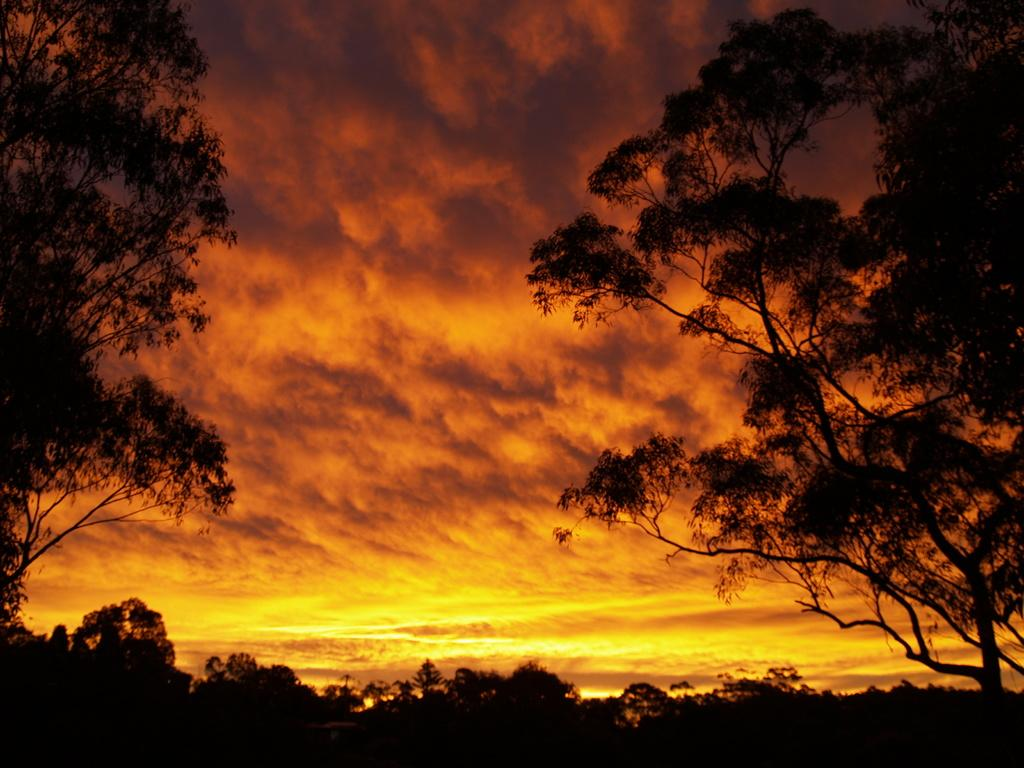What type of vegetation can be seen in the image? There are trees in the image. What is visible in the background of the image? The sky is visible in the background of the image. What can be observed in the sky? Clouds are present in the sky. How many women are wearing scarves in the image? There are no women or scarves present in the image. What are the women doing with their hands in the image? There are no women or hands present in the image. 